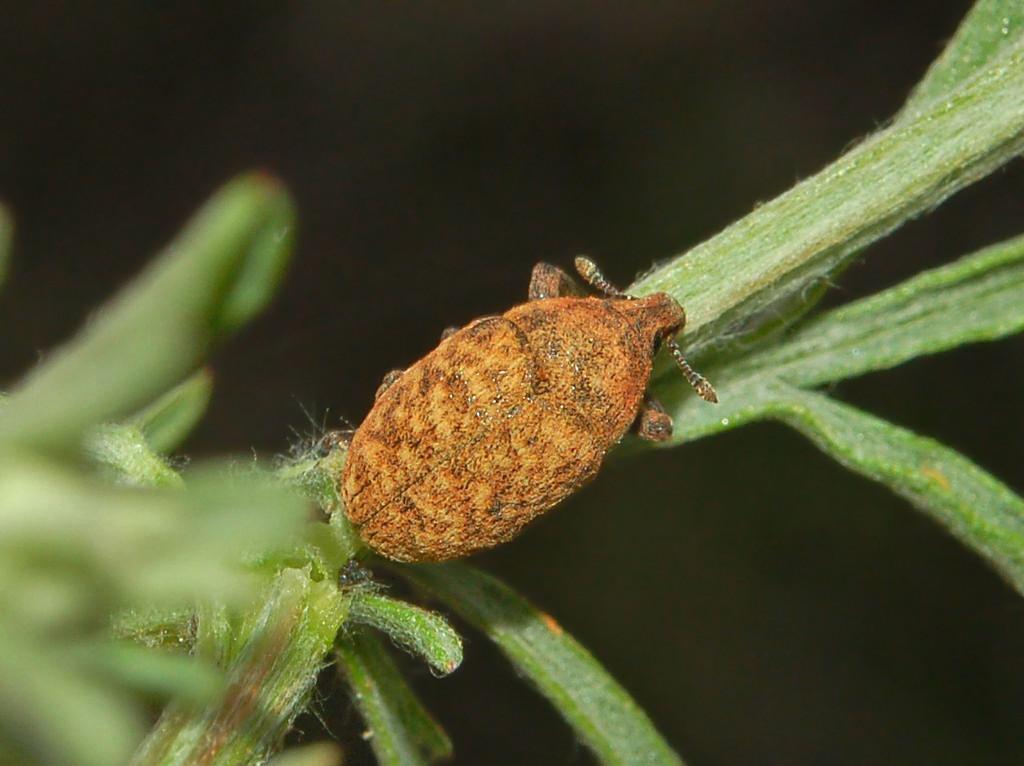Can you describe this image briefly? In the center of the image we can see one plant. On the plant,we can see one insect,which is in brown color. 